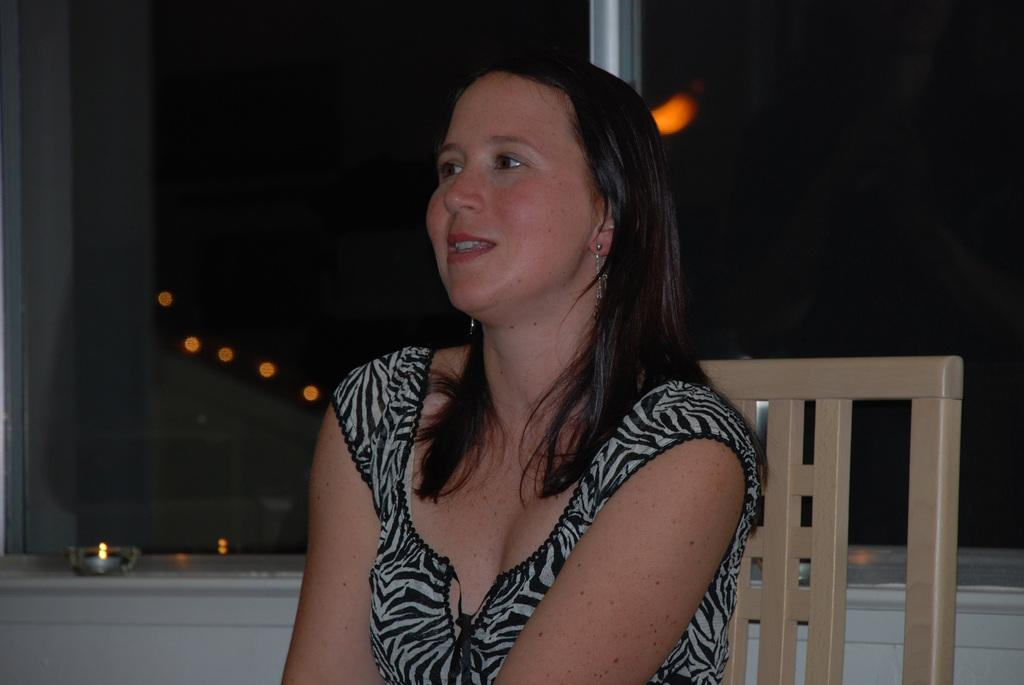What is the woman doing in the image? The woman is sitting on a chair in the image. What is the purpose of the glass window in the image? The glass window is attached to a wall in the image. What is placed near the window? There is a candle near the window in the image. What can be observed about the environment outside the window? It is dark outside the window in the image. What type of agreement is being discussed near the quiver in the image? There is no quiver present in the image, and therefore no agreement can be discussed near it. 